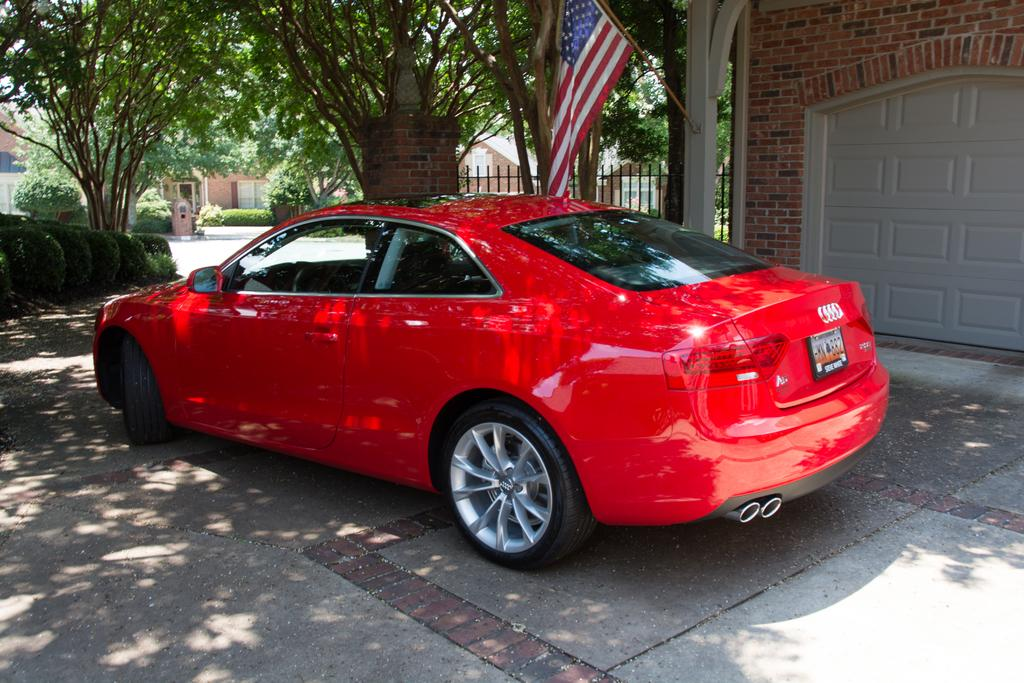What is the main subject in the center of the image? There is a car in the center of the image. What can be seen in the background of the image? There are trees, houses, and a flag in the background of the image. What type of chin can be seen on the car in the image? There is no chin present on the car in the image, as cars do not have chins. 